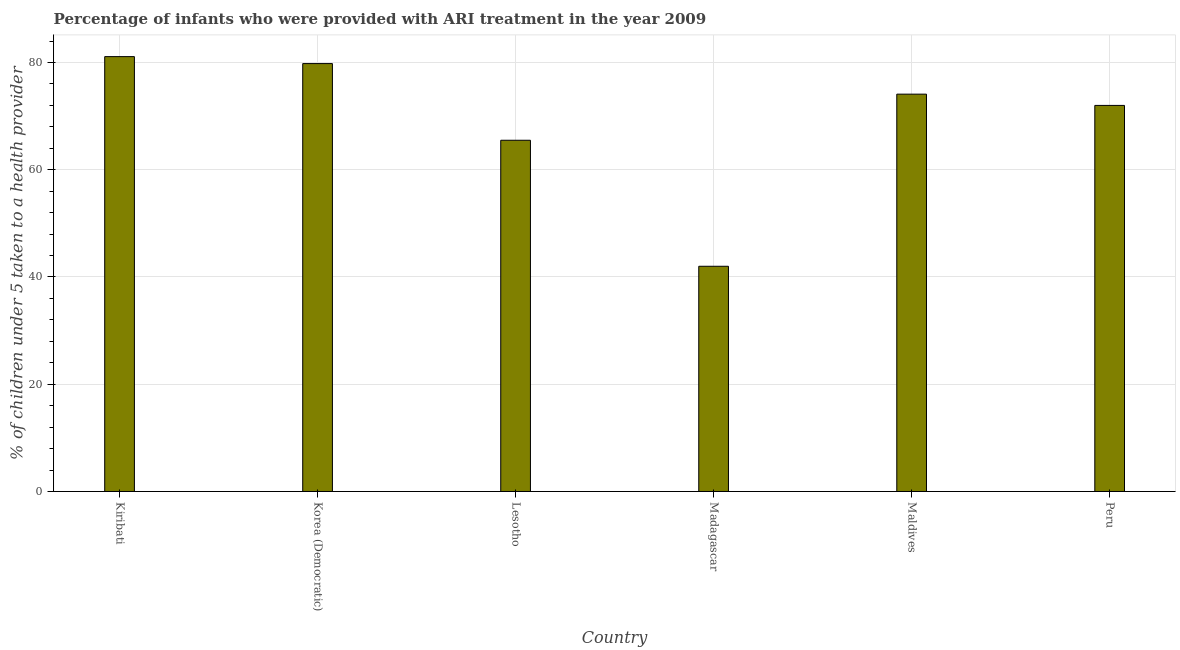What is the title of the graph?
Provide a succinct answer. Percentage of infants who were provided with ARI treatment in the year 2009. What is the label or title of the X-axis?
Offer a very short reply. Country. What is the label or title of the Y-axis?
Your answer should be very brief. % of children under 5 taken to a health provider. What is the percentage of children who were provided with ari treatment in Kiribati?
Ensure brevity in your answer.  81.1. Across all countries, what is the maximum percentage of children who were provided with ari treatment?
Your answer should be very brief. 81.1. In which country was the percentage of children who were provided with ari treatment maximum?
Keep it short and to the point. Kiribati. In which country was the percentage of children who were provided with ari treatment minimum?
Provide a succinct answer. Madagascar. What is the sum of the percentage of children who were provided with ari treatment?
Give a very brief answer. 414.5. What is the average percentage of children who were provided with ari treatment per country?
Give a very brief answer. 69.08. What is the median percentage of children who were provided with ari treatment?
Make the answer very short. 73.05. In how many countries, is the percentage of children who were provided with ari treatment greater than 28 %?
Ensure brevity in your answer.  6. What is the ratio of the percentage of children who were provided with ari treatment in Kiribati to that in Lesotho?
Your response must be concise. 1.24. Is the percentage of children who were provided with ari treatment in Kiribati less than that in Madagascar?
Give a very brief answer. No. Is the difference between the percentage of children who were provided with ari treatment in Kiribati and Maldives greater than the difference between any two countries?
Give a very brief answer. No. What is the difference between the highest and the lowest percentage of children who were provided with ari treatment?
Offer a very short reply. 39.1. Are all the bars in the graph horizontal?
Your answer should be compact. No. What is the % of children under 5 taken to a health provider of Kiribati?
Offer a terse response. 81.1. What is the % of children under 5 taken to a health provider of Korea (Democratic)?
Your response must be concise. 79.8. What is the % of children under 5 taken to a health provider of Lesotho?
Your answer should be compact. 65.5. What is the % of children under 5 taken to a health provider in Madagascar?
Your answer should be compact. 42. What is the % of children under 5 taken to a health provider of Maldives?
Your answer should be compact. 74.1. What is the difference between the % of children under 5 taken to a health provider in Kiribati and Korea (Democratic)?
Make the answer very short. 1.3. What is the difference between the % of children under 5 taken to a health provider in Kiribati and Lesotho?
Provide a succinct answer. 15.6. What is the difference between the % of children under 5 taken to a health provider in Kiribati and Madagascar?
Give a very brief answer. 39.1. What is the difference between the % of children under 5 taken to a health provider in Korea (Democratic) and Lesotho?
Ensure brevity in your answer.  14.3. What is the difference between the % of children under 5 taken to a health provider in Korea (Democratic) and Madagascar?
Offer a very short reply. 37.8. What is the difference between the % of children under 5 taken to a health provider in Korea (Democratic) and Peru?
Your answer should be very brief. 7.8. What is the difference between the % of children under 5 taken to a health provider in Madagascar and Maldives?
Offer a very short reply. -32.1. What is the ratio of the % of children under 5 taken to a health provider in Kiribati to that in Lesotho?
Your response must be concise. 1.24. What is the ratio of the % of children under 5 taken to a health provider in Kiribati to that in Madagascar?
Make the answer very short. 1.93. What is the ratio of the % of children under 5 taken to a health provider in Kiribati to that in Maldives?
Make the answer very short. 1.09. What is the ratio of the % of children under 5 taken to a health provider in Kiribati to that in Peru?
Keep it short and to the point. 1.13. What is the ratio of the % of children under 5 taken to a health provider in Korea (Democratic) to that in Lesotho?
Your answer should be very brief. 1.22. What is the ratio of the % of children under 5 taken to a health provider in Korea (Democratic) to that in Madagascar?
Your answer should be compact. 1.9. What is the ratio of the % of children under 5 taken to a health provider in Korea (Democratic) to that in Maldives?
Give a very brief answer. 1.08. What is the ratio of the % of children under 5 taken to a health provider in Korea (Democratic) to that in Peru?
Offer a terse response. 1.11. What is the ratio of the % of children under 5 taken to a health provider in Lesotho to that in Madagascar?
Your response must be concise. 1.56. What is the ratio of the % of children under 5 taken to a health provider in Lesotho to that in Maldives?
Provide a short and direct response. 0.88. What is the ratio of the % of children under 5 taken to a health provider in Lesotho to that in Peru?
Give a very brief answer. 0.91. What is the ratio of the % of children under 5 taken to a health provider in Madagascar to that in Maldives?
Ensure brevity in your answer.  0.57. What is the ratio of the % of children under 5 taken to a health provider in Madagascar to that in Peru?
Offer a very short reply. 0.58. What is the ratio of the % of children under 5 taken to a health provider in Maldives to that in Peru?
Ensure brevity in your answer.  1.03. 